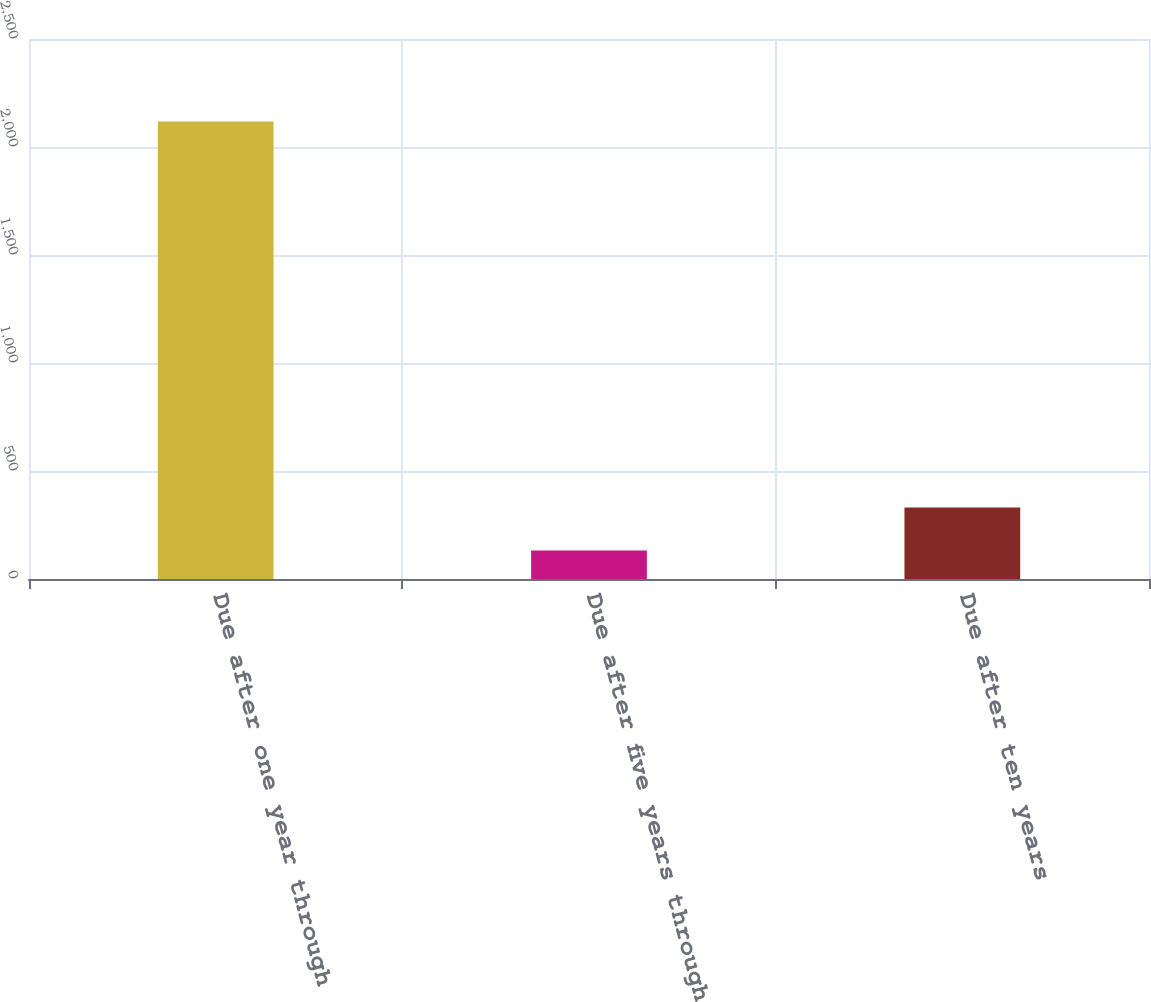<chart> <loc_0><loc_0><loc_500><loc_500><bar_chart><fcel>Due after one year through<fcel>Due after five years through<fcel>Due after ten years<nl><fcel>2118<fcel>132<fcel>330.6<nl></chart> 